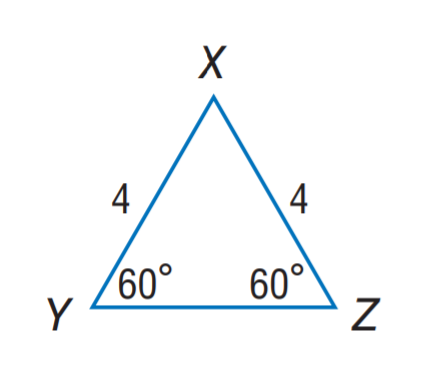Answer the mathemtical geometry problem and directly provide the correct option letter.
Question: Find Y Z.
Choices: A: 2 B: 4 C: 6 D: 8 B 